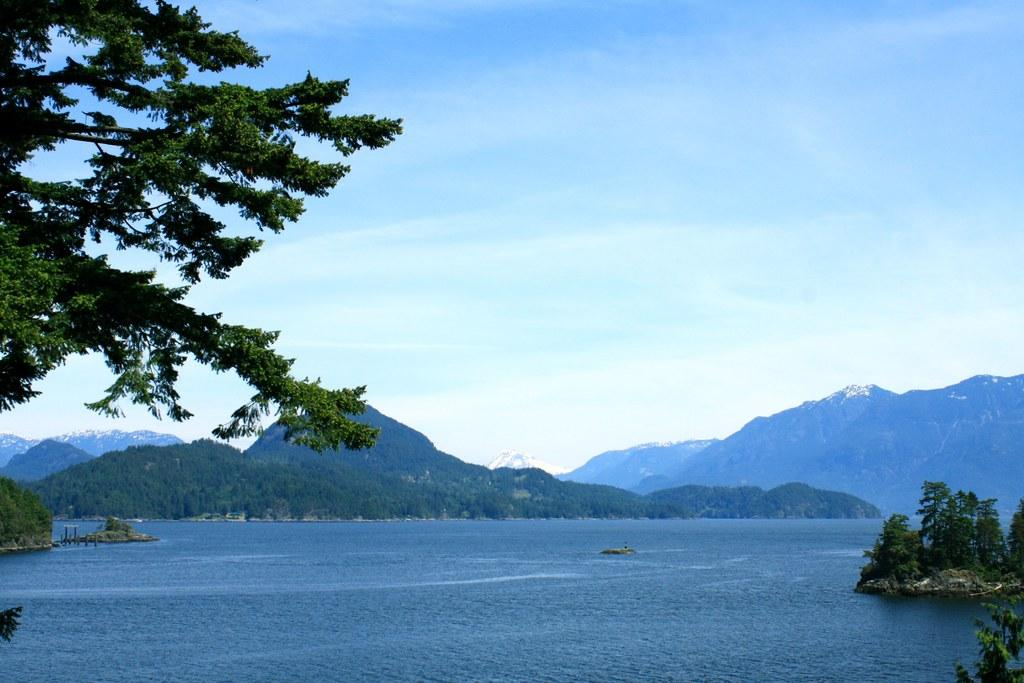What is the primary element visible in the image? There is water in the image. What type of vegetation can be seen in the image? There are trees in the image. What geographical feature is visible in the background of the image? There is a mountain in the background of the image. What else can be seen in the background of the image? The sky is visible in the background of the image. How many babies are sitting on the stone in the image? There are no babies or stones present in the image. 